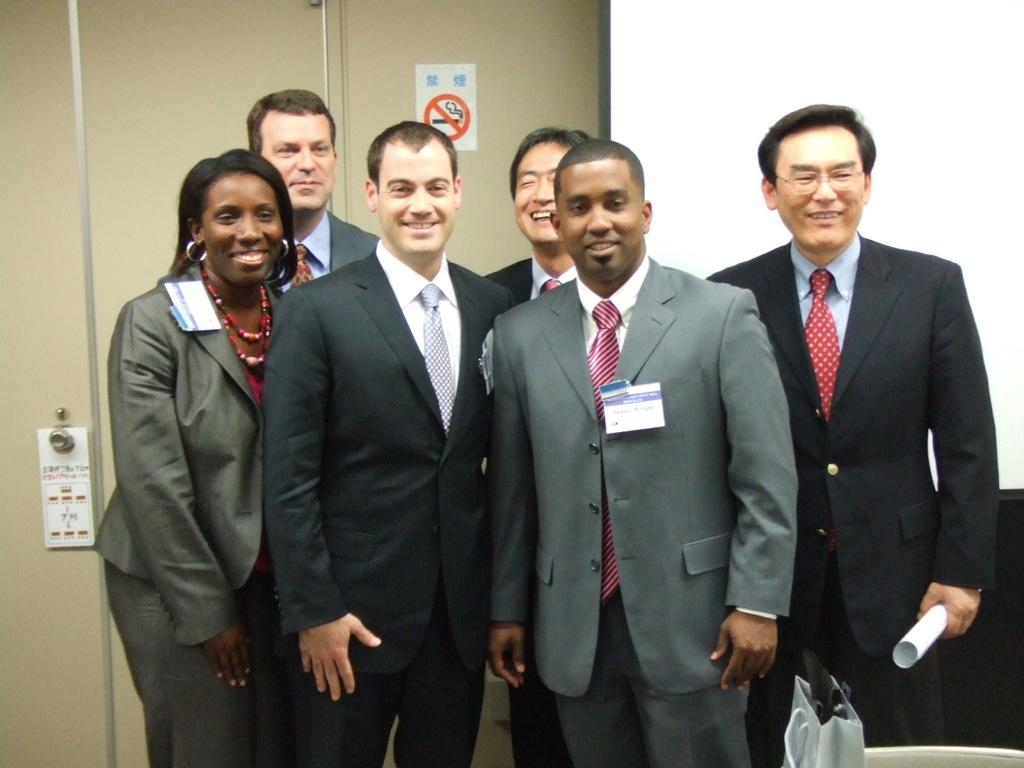What is happening in the center of the image? There are people standing in the center of the image. What can be seen in the background of the image? There is a wall and a door in the background of the image. What type of peace symbol can be seen hanging on the wall in the image? There is no peace symbol visible in the image; only a wall and a door are present in the background. 